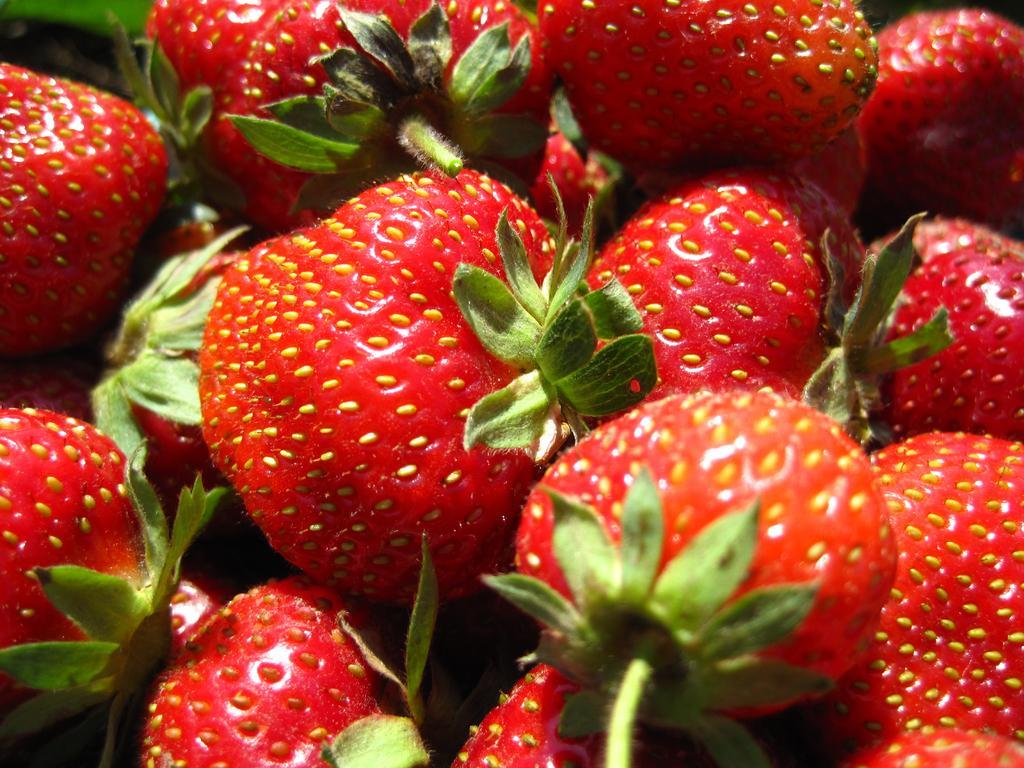Please provide a concise description of this image. In this picture I can see some fruits. 